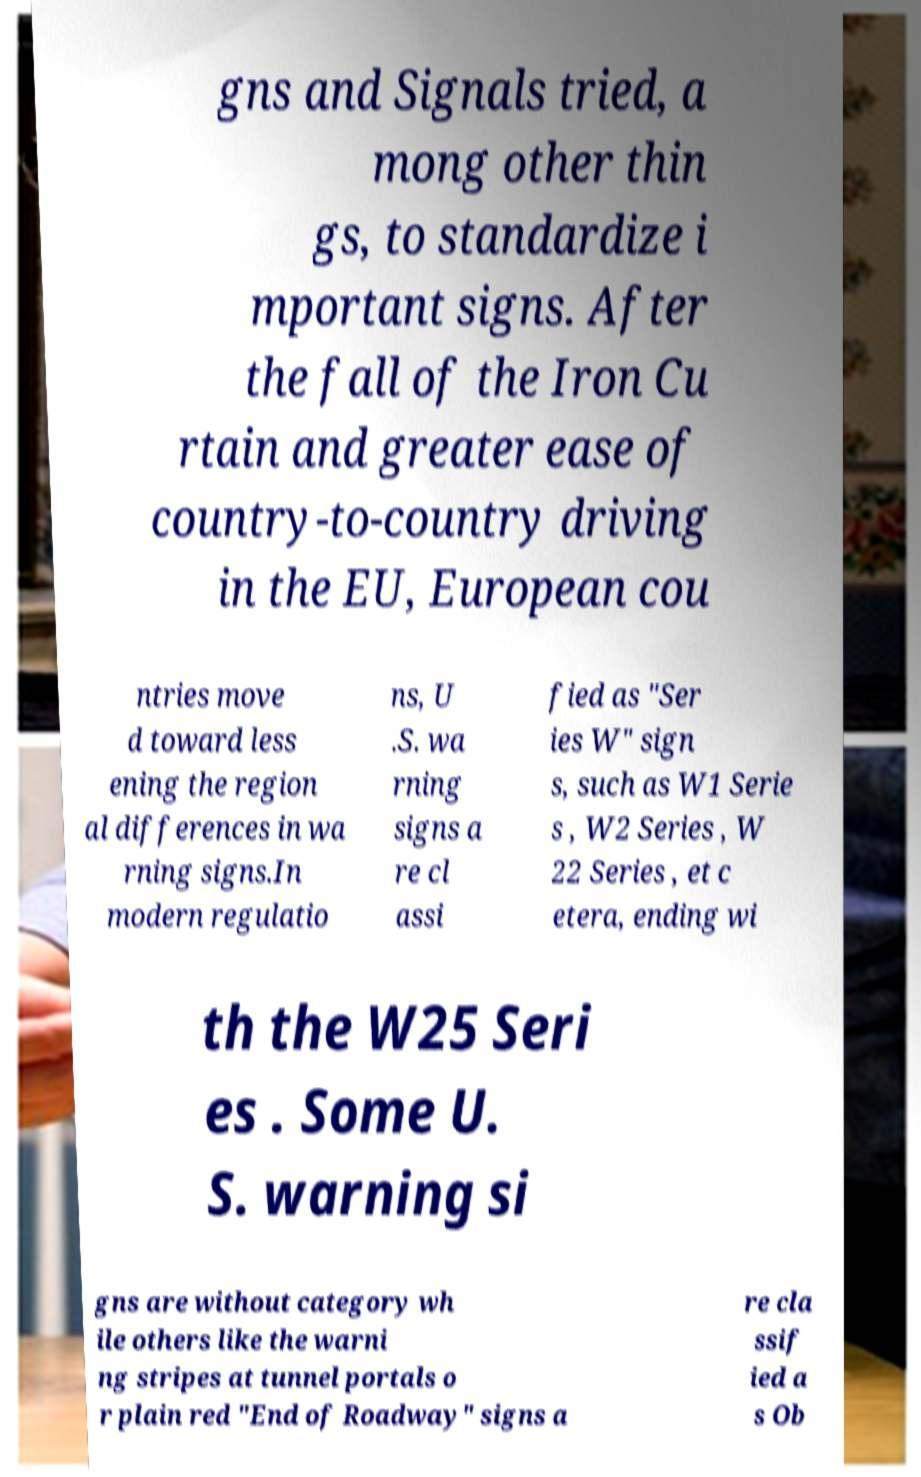There's text embedded in this image that I need extracted. Can you transcribe it verbatim? gns and Signals tried, a mong other thin gs, to standardize i mportant signs. After the fall of the Iron Cu rtain and greater ease of country-to-country driving in the EU, European cou ntries move d toward less ening the region al differences in wa rning signs.In modern regulatio ns, U .S. wa rning signs a re cl assi fied as "Ser ies W" sign s, such as W1 Serie s , W2 Series , W 22 Series , et c etera, ending wi th the W25 Seri es . Some U. S. warning si gns are without category wh ile others like the warni ng stripes at tunnel portals o r plain red "End of Roadway" signs a re cla ssif ied a s Ob 